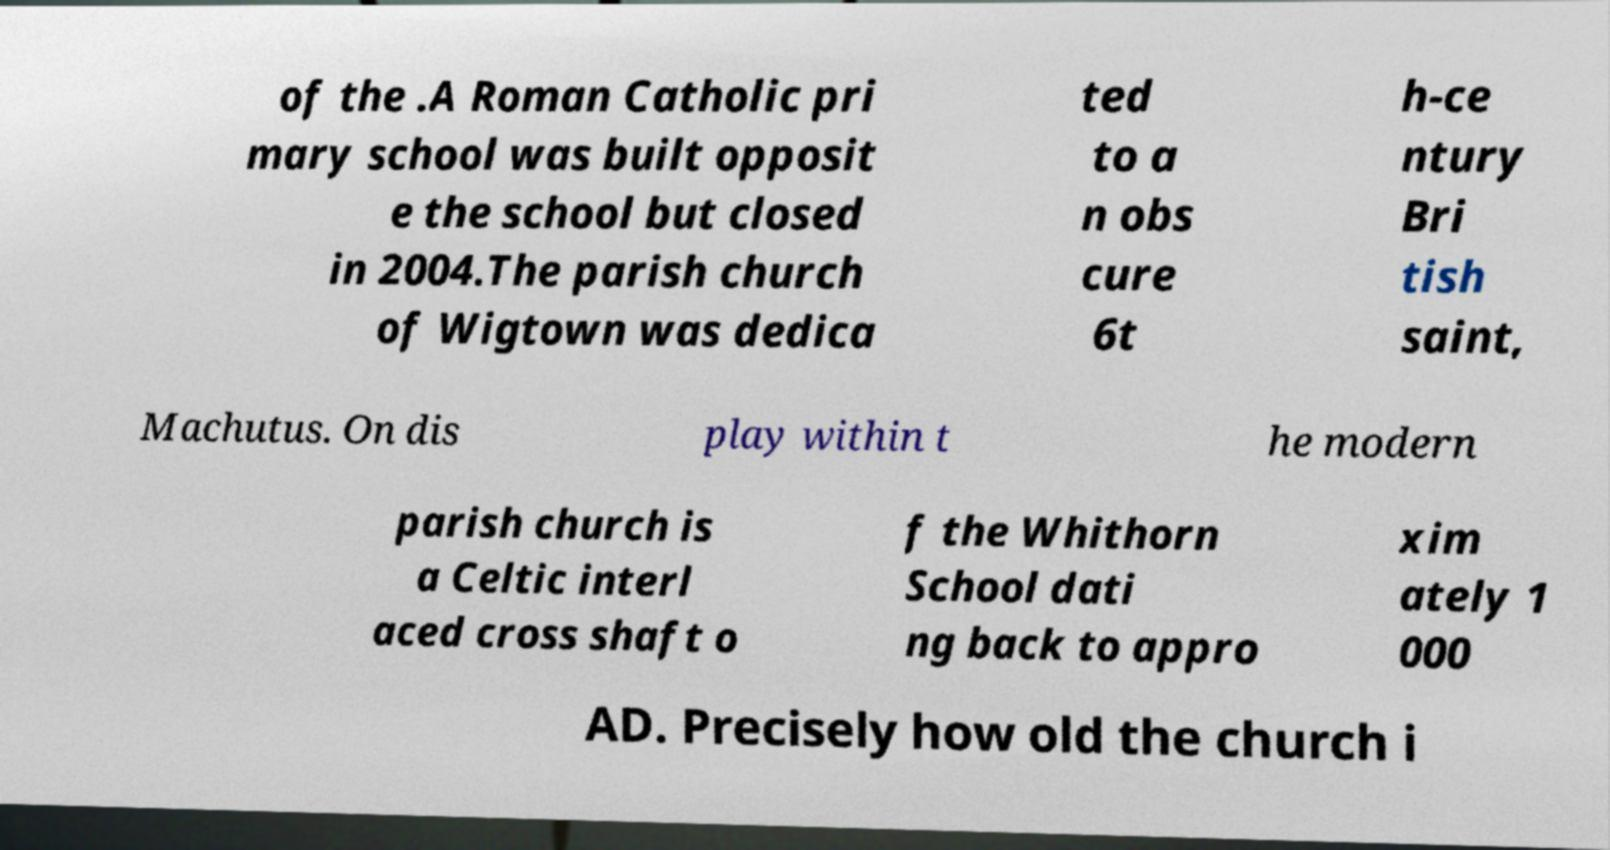Can you accurately transcribe the text from the provided image for me? of the .A Roman Catholic pri mary school was built opposit e the school but closed in 2004.The parish church of Wigtown was dedica ted to a n obs cure 6t h-ce ntury Bri tish saint, Machutus. On dis play within t he modern parish church is a Celtic interl aced cross shaft o f the Whithorn School dati ng back to appro xim ately 1 000 AD. Precisely how old the church i 